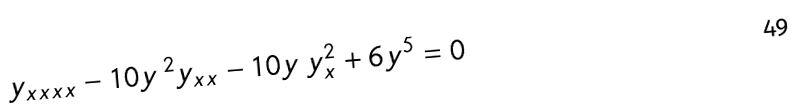Convert formula to latex. <formula><loc_0><loc_0><loc_500><loc_500>y _ { x x x x } - 1 0 y \, ^ { 2 } y _ { x x } - 1 0 y \, y _ { x } ^ { 2 } + 6 y ^ { 5 } = 0</formula> 